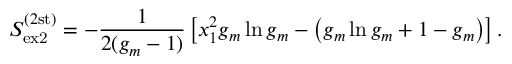<formula> <loc_0><loc_0><loc_500><loc_500>S _ { e x 2 } ^ { ( 2 s t ) } = - \frac { 1 } { 2 ( g _ { m } - 1 ) } \left [ x _ { 1 } ^ { 2 } g _ { m } \ln g _ { m } - \left ( g _ { m } \ln g _ { m } + 1 - g _ { m } \right ) \right ] .</formula> 